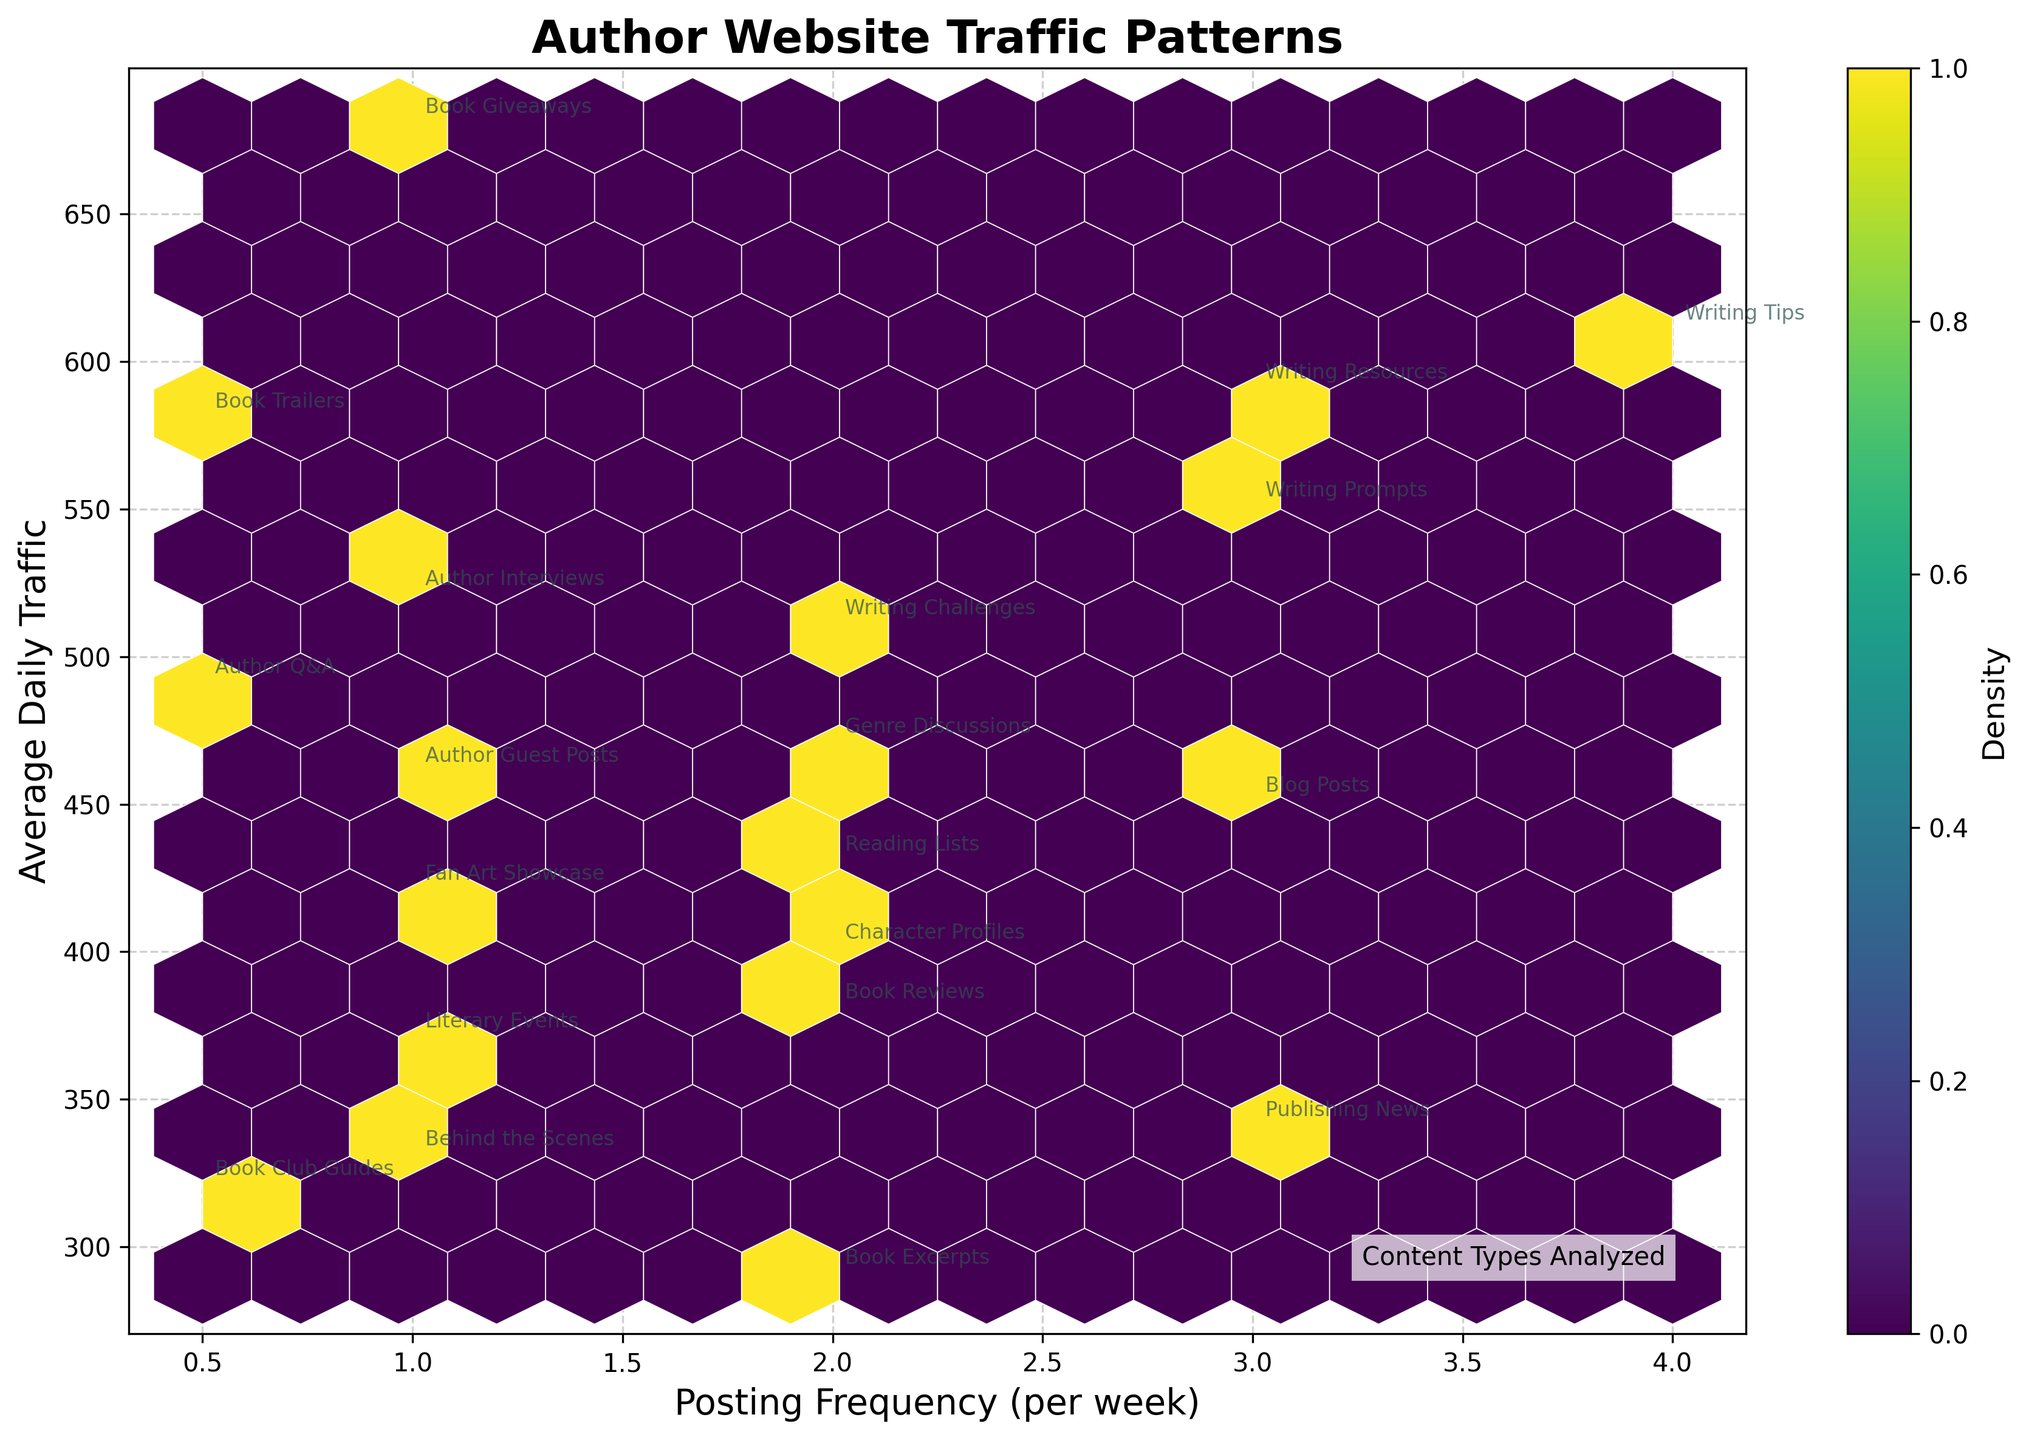What does the title of the plot say? The title of the plot is typically displayed prominently at the top of the figure. For this plot, it reads "Author Website Traffic Patterns."
Answer: Author Website Traffic Patterns What do the x and y axes represent? The x-axis represents "Posting Frequency (per week)" and the y-axis represents "Average Daily Traffic," clearly labeled on the figure.
Answer: Posting Frequency (per week) and Average Daily Traffic Which content type appears most frequently with high traffic numbers? By examining the hexbin density and annotations, "Writing Tips" pops up frequently with a high Average Daily Traffic (610).
Answer: Writing Tips What is the general correlation between posting frequency and average daily traffic? Observing the hexbin density distribution, a positive correlation is noticeable where more frequent postings typically correlate with higher daily traffic.
Answer: Positive correlation Which range of posting frequencies shows the highest density of data points? By looking at the hexbin plot, the area with the highest density of hexagons appears around 2-3 posts per week.
Answer: 2-3 posts per week What's the average daily traffic for content types posted 0.5 times per week? Checking the annotations near 0.5 on the x-axis, the average daily traffic for "Book Trailers," "Author Q&A," and "Book Club Guides" are 580, 490, and 320 respectively. Averaging these values: (580+490+320)/3 = 463.33.
Answer: 463.33 How does the density of "Writing Resources" compare to "Literary Events"? "Writing Resources" (Posting Frequency 3, Traffic 590) falls within a denser region of the hexbin plot compared to "Literary Events" (Posting Frequency 1, Traffic 1370). This implies that "Writing Resources" is more common within its traffic frequency range.
Answer: "Writing Resources" is in a denser region Is there a visible outlier in the plot? By checking for isolated points far from denser clusters, "Literary Events" (Frequency 1, Traffic 1370) stands out, indicating it might be an outlier.
Answer: Literary Events at (1, 1370) Which content type has the lowest average daily traffic, and what is its posting frequency? Reviewing the annotated points, "Book Club Guides" has the lowest traffic of 320 and a posting frequency of 0.5.
Answer: Book Club Guides with 0.5 per week Does higher posting frequency guarantee higher average daily traffic? While high posting frequency usually correlates with higher traffic, some low-frequency content like "Author Interviews" (1, Traffic 520) still have high traffic, indicating other factors at play.
Answer: Not guaranteed 